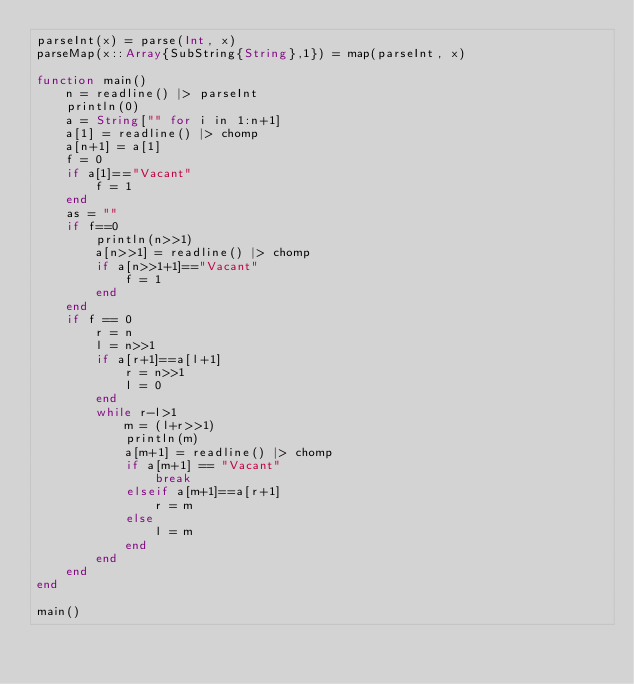<code> <loc_0><loc_0><loc_500><loc_500><_Julia_>parseInt(x) = parse(Int, x)
parseMap(x::Array{SubString{String},1}) = map(parseInt, x)

function main()
	n = readline() |> parseInt
	println(0)
	a = String["" for i in 1:n+1]
	a[1] = readline() |> chomp
	a[n+1] = a[1]
	f = 0
	if a[1]=="Vacant"
		f = 1
	end
	as = ""
	if f==0
		println(n>>1)
		a[n>>1] = readline() |> chomp
		if a[n>>1+1]=="Vacant"
			f = 1
		end
	end
	if f == 0
		r = n
		l = n>>1
		if a[r+1]==a[l+1]
			r = n>>1
			l = 0
		end
		while r-l>1
			m = (l+r>>1)
			println(m)
			a[m+1] = readline() |> chomp
			if a[m+1] == "Vacant"
				break
			elseif a[m+1]==a[r+1]
				r = m
			else
				l = m
			end
		end
	end
end

main()</code> 